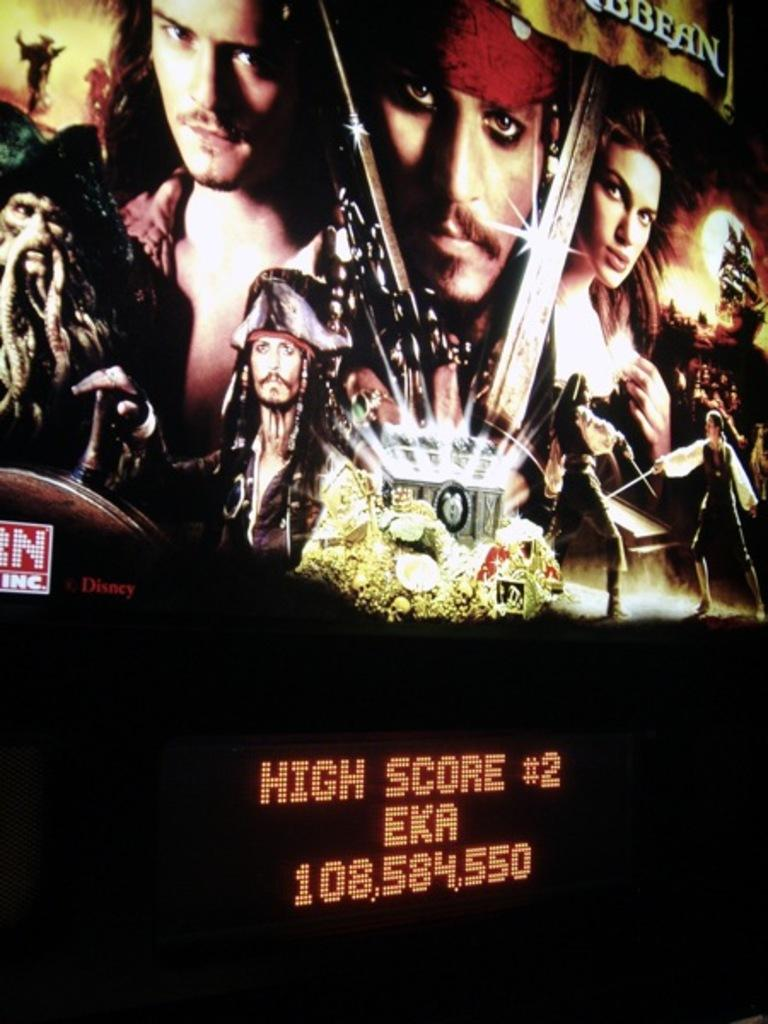<image>
Describe the image concisely. Someone playing a Pirates of the Caribbean game got the second highest score. 